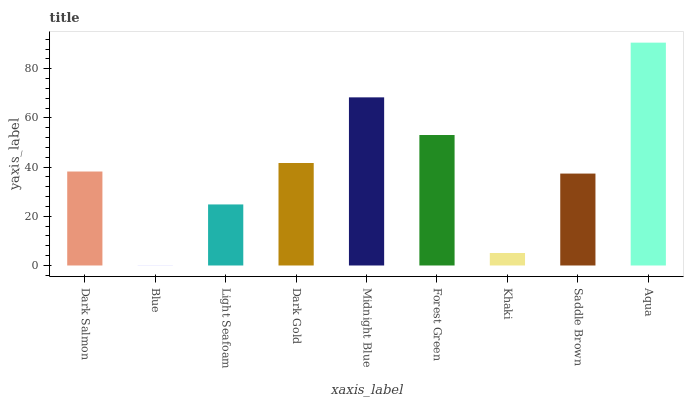Is Blue the minimum?
Answer yes or no. Yes. Is Aqua the maximum?
Answer yes or no. Yes. Is Light Seafoam the minimum?
Answer yes or no. No. Is Light Seafoam the maximum?
Answer yes or no. No. Is Light Seafoam greater than Blue?
Answer yes or no. Yes. Is Blue less than Light Seafoam?
Answer yes or no. Yes. Is Blue greater than Light Seafoam?
Answer yes or no. No. Is Light Seafoam less than Blue?
Answer yes or no. No. Is Dark Salmon the high median?
Answer yes or no. Yes. Is Dark Salmon the low median?
Answer yes or no. Yes. Is Saddle Brown the high median?
Answer yes or no. No. Is Forest Green the low median?
Answer yes or no. No. 